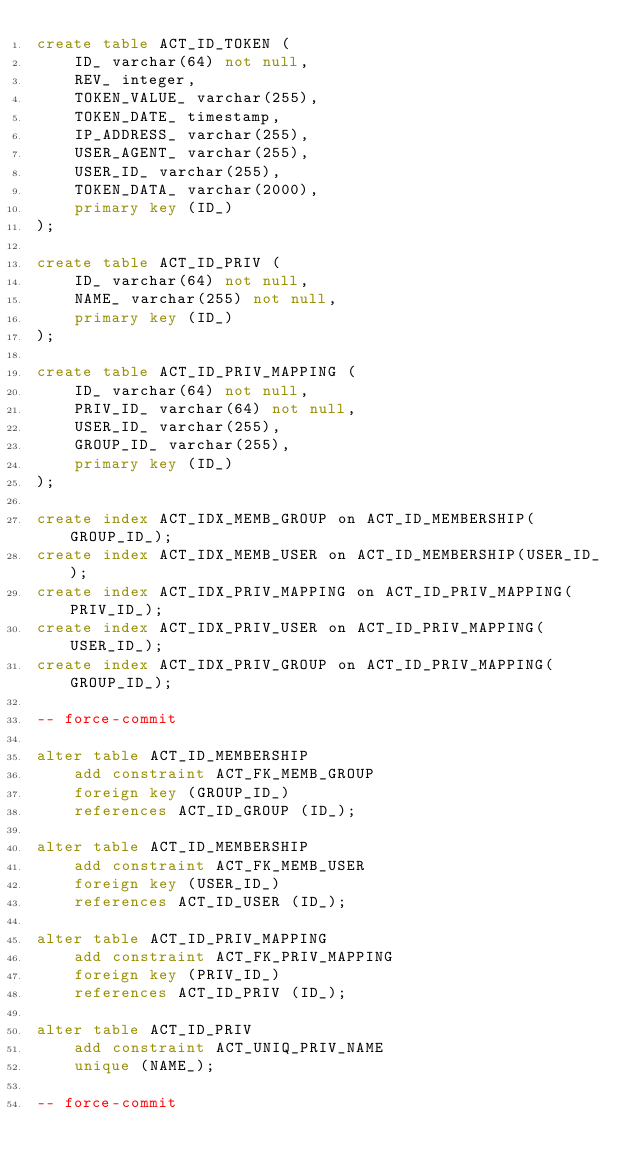<code> <loc_0><loc_0><loc_500><loc_500><_SQL_>create table ACT_ID_TOKEN (
    ID_ varchar(64) not null,
    REV_ integer,
    TOKEN_VALUE_ varchar(255),
    TOKEN_DATE_ timestamp,
    IP_ADDRESS_ varchar(255),
    USER_AGENT_ varchar(255),
    USER_ID_ varchar(255),
    TOKEN_DATA_ varchar(2000),
    primary key (ID_)
);

create table ACT_ID_PRIV (
    ID_ varchar(64) not null,
    NAME_ varchar(255) not null,
    primary key (ID_)
);

create table ACT_ID_PRIV_MAPPING (
    ID_ varchar(64) not null,
    PRIV_ID_ varchar(64) not null,
    USER_ID_ varchar(255),
    GROUP_ID_ varchar(255),
    primary key (ID_)
);

create index ACT_IDX_MEMB_GROUP on ACT_ID_MEMBERSHIP(GROUP_ID_);
create index ACT_IDX_MEMB_USER on ACT_ID_MEMBERSHIP(USER_ID_);
create index ACT_IDX_PRIV_MAPPING on ACT_ID_PRIV_MAPPING(PRIV_ID_);
create index ACT_IDX_PRIV_USER on ACT_ID_PRIV_MAPPING(USER_ID_);
create index ACT_IDX_PRIV_GROUP on ACT_ID_PRIV_MAPPING(GROUP_ID_);

-- force-commit

alter table ACT_ID_MEMBERSHIP
    add constraint ACT_FK_MEMB_GROUP
    foreign key (GROUP_ID_)
    references ACT_ID_GROUP (ID_);

alter table ACT_ID_MEMBERSHIP
    add constraint ACT_FK_MEMB_USER
    foreign key (USER_ID_)
    references ACT_ID_USER (ID_);

alter table ACT_ID_PRIV_MAPPING
    add constraint ACT_FK_PRIV_MAPPING
    foreign key (PRIV_ID_)
    references ACT_ID_PRIV (ID_);

alter table ACT_ID_PRIV
    add constraint ACT_UNIQ_PRIV_NAME
    unique (NAME_);

-- force-commit</code> 